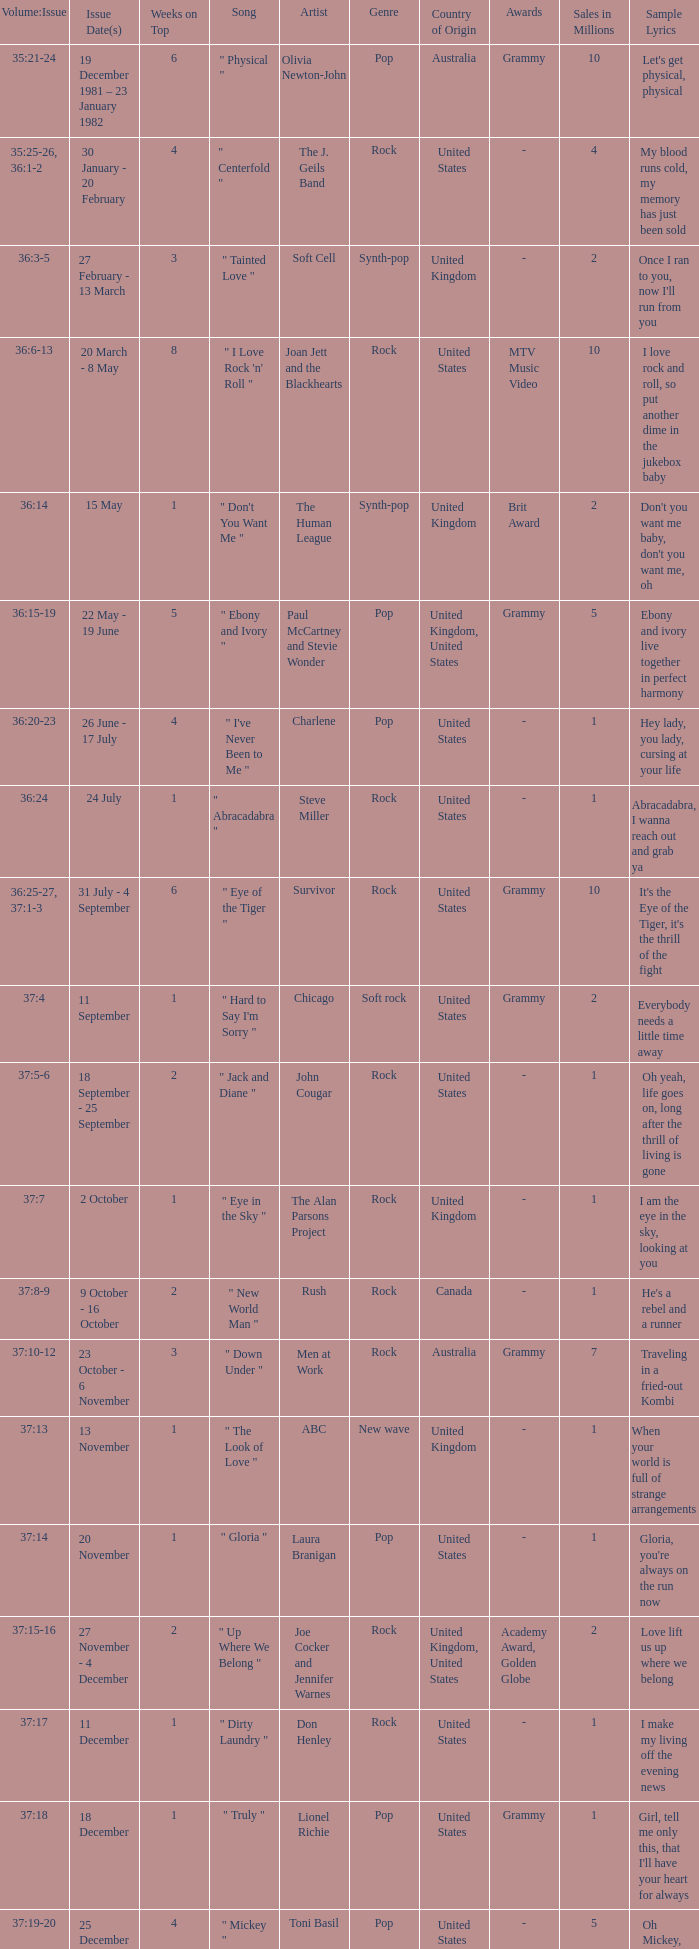Which Weeks on Top have an Issue Date(s) of 20 november? 1.0. 